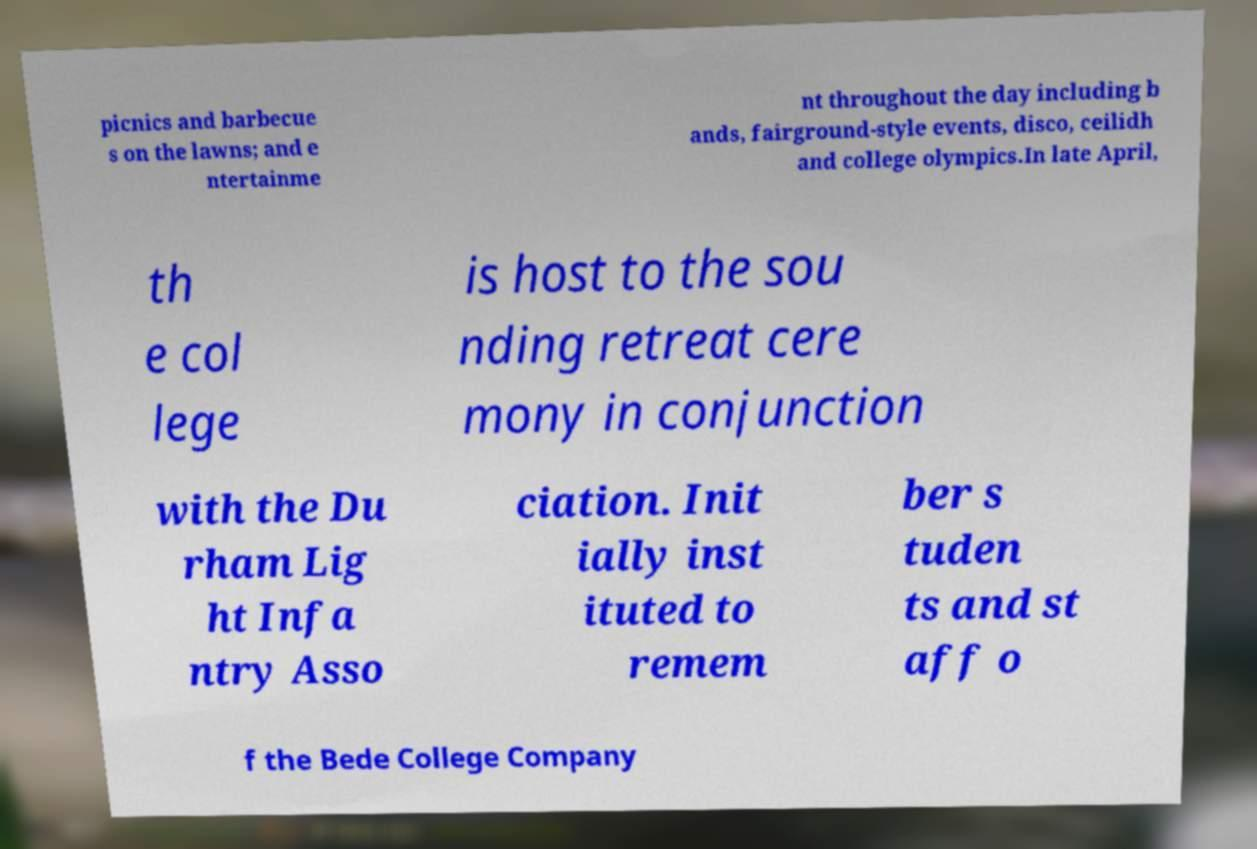I need the written content from this picture converted into text. Can you do that? picnics and barbecue s on the lawns; and e ntertainme nt throughout the day including b ands, fairground-style events, disco, ceilidh and college olympics.In late April, th e col lege is host to the sou nding retreat cere mony in conjunction with the Du rham Lig ht Infa ntry Asso ciation. Init ially inst ituted to remem ber s tuden ts and st aff o f the Bede College Company 